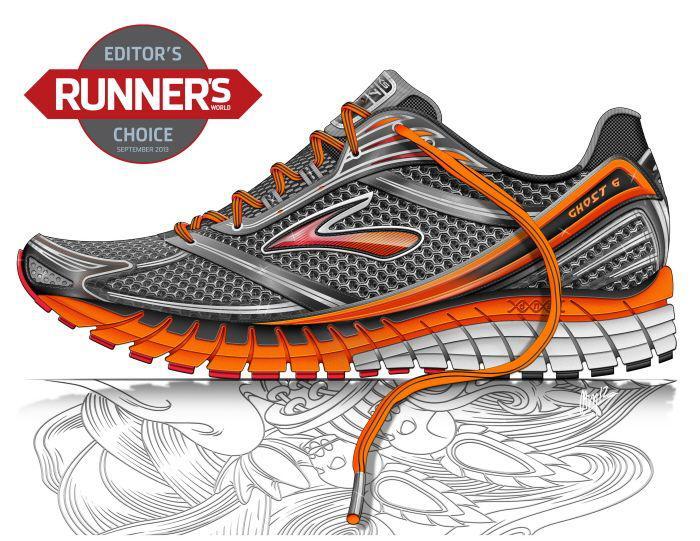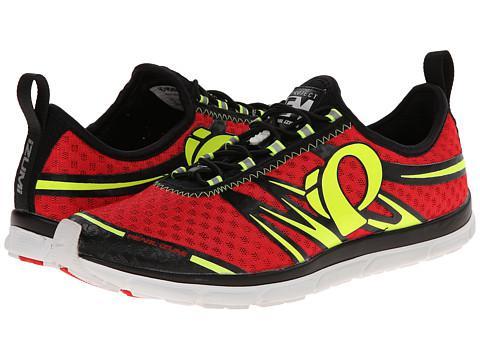The first image is the image on the left, the second image is the image on the right. Analyze the images presented: Is the assertion "Each image contains a single sneaker, and the sneakers in the left and right images face different [left vs right] directions." valid? Answer yes or no. No. The first image is the image on the left, the second image is the image on the right. For the images shown, is this caption "A single shoe sits on a white surface in each of the images." true? Answer yes or no. No. 